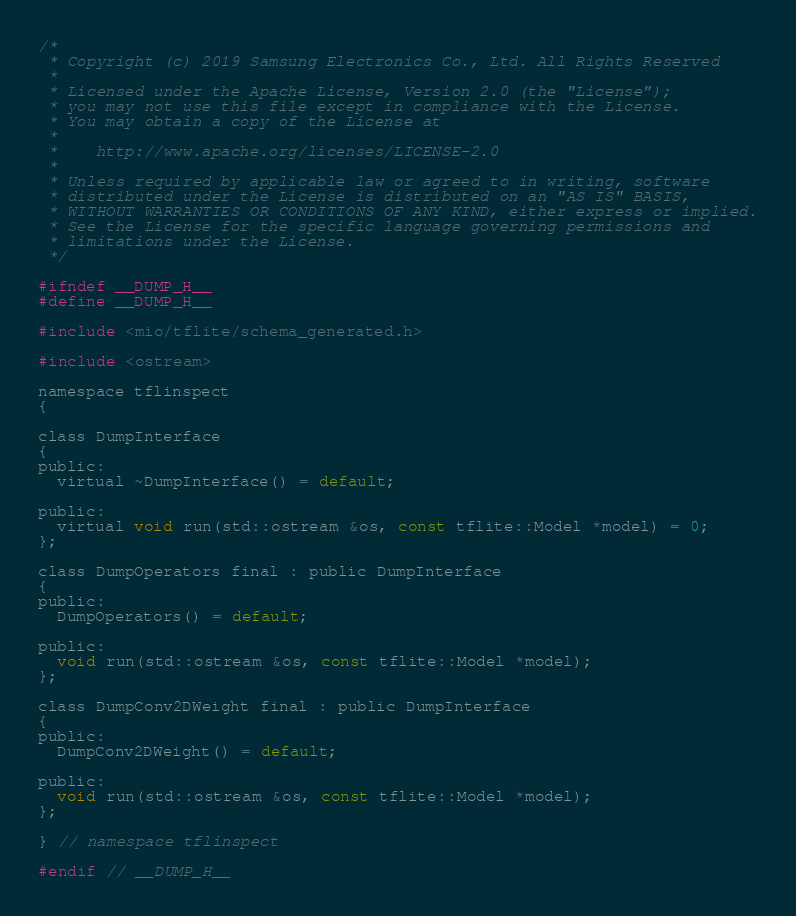<code> <loc_0><loc_0><loc_500><loc_500><_C_>/*
 * Copyright (c) 2019 Samsung Electronics Co., Ltd. All Rights Reserved
 *
 * Licensed under the Apache License, Version 2.0 (the "License");
 * you may not use this file except in compliance with the License.
 * You may obtain a copy of the License at
 *
 *    http://www.apache.org/licenses/LICENSE-2.0
 *
 * Unless required by applicable law or agreed to in writing, software
 * distributed under the License is distributed on an "AS IS" BASIS,
 * WITHOUT WARRANTIES OR CONDITIONS OF ANY KIND, either express or implied.
 * See the License for the specific language governing permissions and
 * limitations under the License.
 */

#ifndef __DUMP_H__
#define __DUMP_H__

#include <mio/tflite/schema_generated.h>

#include <ostream>

namespace tflinspect
{

class DumpInterface
{
public:
  virtual ~DumpInterface() = default;

public:
  virtual void run(std::ostream &os, const tflite::Model *model) = 0;
};

class DumpOperators final : public DumpInterface
{
public:
  DumpOperators() = default;

public:
  void run(std::ostream &os, const tflite::Model *model);
};

class DumpConv2DWeight final : public DumpInterface
{
public:
  DumpConv2DWeight() = default;

public:
  void run(std::ostream &os, const tflite::Model *model);
};

} // namespace tflinspect

#endif // __DUMP_H__
</code> 